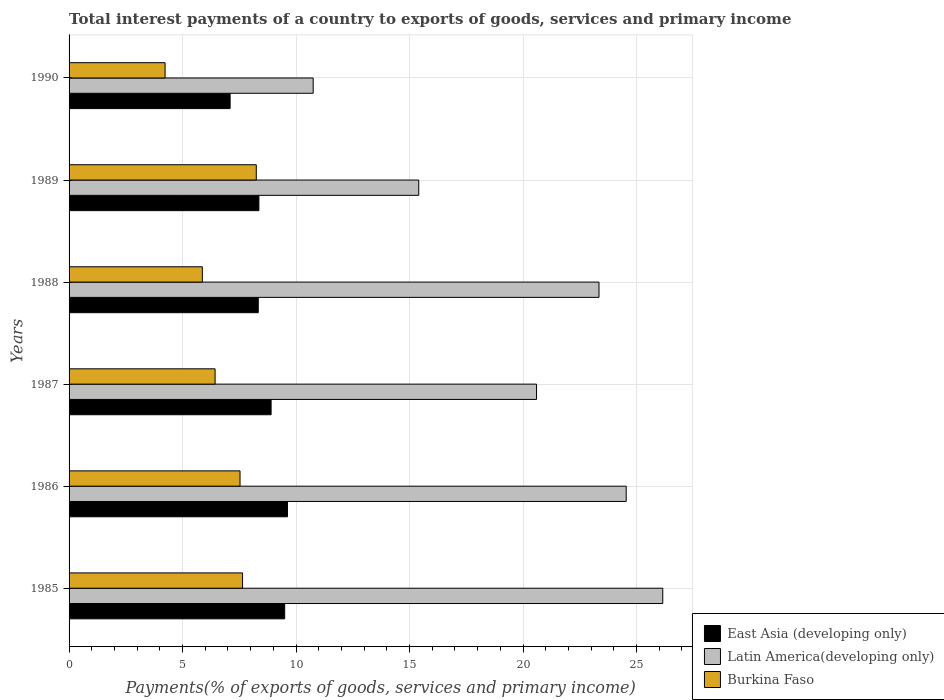How many groups of bars are there?
Give a very brief answer. 6. Are the number of bars on each tick of the Y-axis equal?
Provide a succinct answer. Yes. How many bars are there on the 4th tick from the top?
Your answer should be compact. 3. What is the label of the 6th group of bars from the top?
Your answer should be compact. 1985. In how many cases, is the number of bars for a given year not equal to the number of legend labels?
Make the answer very short. 0. What is the total interest payments in Latin America(developing only) in 1987?
Ensure brevity in your answer.  20.59. Across all years, what is the maximum total interest payments in East Asia (developing only)?
Make the answer very short. 9.62. Across all years, what is the minimum total interest payments in Latin America(developing only)?
Make the answer very short. 10.75. In which year was the total interest payments in Latin America(developing only) maximum?
Make the answer very short. 1985. In which year was the total interest payments in East Asia (developing only) minimum?
Give a very brief answer. 1990. What is the total total interest payments in Latin America(developing only) in the graph?
Keep it short and to the point. 120.8. What is the difference between the total interest payments in East Asia (developing only) in 1987 and that in 1989?
Your answer should be very brief. 0.54. What is the difference between the total interest payments in Burkina Faso in 1990 and the total interest payments in Latin America(developing only) in 1985?
Make the answer very short. -21.92. What is the average total interest payments in East Asia (developing only) per year?
Provide a short and direct response. 8.64. In the year 1989, what is the difference between the total interest payments in East Asia (developing only) and total interest payments in Latin America(developing only)?
Offer a terse response. -7.04. In how many years, is the total interest payments in East Asia (developing only) greater than 5 %?
Keep it short and to the point. 6. What is the ratio of the total interest payments in Latin America(developing only) in 1985 to that in 1988?
Offer a terse response. 1.12. Is the total interest payments in East Asia (developing only) in 1986 less than that in 1990?
Your answer should be compact. No. What is the difference between the highest and the second highest total interest payments in East Asia (developing only)?
Provide a succinct answer. 0.12. What is the difference between the highest and the lowest total interest payments in Burkina Faso?
Your answer should be very brief. 4.02. What does the 1st bar from the top in 1985 represents?
Provide a succinct answer. Burkina Faso. What does the 2nd bar from the bottom in 1989 represents?
Provide a succinct answer. Latin America(developing only). Is it the case that in every year, the sum of the total interest payments in East Asia (developing only) and total interest payments in Latin America(developing only) is greater than the total interest payments in Burkina Faso?
Make the answer very short. Yes. Are all the bars in the graph horizontal?
Your answer should be compact. Yes. How many years are there in the graph?
Your answer should be compact. 6. Are the values on the major ticks of X-axis written in scientific E-notation?
Your answer should be very brief. No. Does the graph contain any zero values?
Your response must be concise. No. How many legend labels are there?
Provide a short and direct response. 3. How are the legend labels stacked?
Provide a succinct answer. Vertical. What is the title of the graph?
Your answer should be very brief. Total interest payments of a country to exports of goods, services and primary income. Does "Peru" appear as one of the legend labels in the graph?
Offer a terse response. No. What is the label or title of the X-axis?
Your answer should be very brief. Payments(% of exports of goods, services and primary income). What is the label or title of the Y-axis?
Your answer should be compact. Years. What is the Payments(% of exports of goods, services and primary income) in East Asia (developing only) in 1985?
Your response must be concise. 9.5. What is the Payments(% of exports of goods, services and primary income) in Latin America(developing only) in 1985?
Ensure brevity in your answer.  26.15. What is the Payments(% of exports of goods, services and primary income) of Burkina Faso in 1985?
Give a very brief answer. 7.64. What is the Payments(% of exports of goods, services and primary income) in East Asia (developing only) in 1986?
Offer a very short reply. 9.62. What is the Payments(% of exports of goods, services and primary income) of Latin America(developing only) in 1986?
Your answer should be very brief. 24.54. What is the Payments(% of exports of goods, services and primary income) of Burkina Faso in 1986?
Provide a succinct answer. 7.53. What is the Payments(% of exports of goods, services and primary income) of East Asia (developing only) in 1987?
Your answer should be compact. 8.9. What is the Payments(% of exports of goods, services and primary income) of Latin America(developing only) in 1987?
Give a very brief answer. 20.59. What is the Payments(% of exports of goods, services and primary income) in Burkina Faso in 1987?
Offer a very short reply. 6.43. What is the Payments(% of exports of goods, services and primary income) of East Asia (developing only) in 1988?
Ensure brevity in your answer.  8.33. What is the Payments(% of exports of goods, services and primary income) in Latin America(developing only) in 1988?
Ensure brevity in your answer.  23.35. What is the Payments(% of exports of goods, services and primary income) in Burkina Faso in 1988?
Keep it short and to the point. 5.87. What is the Payments(% of exports of goods, services and primary income) of East Asia (developing only) in 1989?
Make the answer very short. 8.36. What is the Payments(% of exports of goods, services and primary income) of Latin America(developing only) in 1989?
Offer a very short reply. 15.4. What is the Payments(% of exports of goods, services and primary income) of Burkina Faso in 1989?
Your answer should be very brief. 8.25. What is the Payments(% of exports of goods, services and primary income) in East Asia (developing only) in 1990?
Your answer should be compact. 7.09. What is the Payments(% of exports of goods, services and primary income) of Latin America(developing only) in 1990?
Offer a very short reply. 10.75. What is the Payments(% of exports of goods, services and primary income) in Burkina Faso in 1990?
Provide a succinct answer. 4.23. Across all years, what is the maximum Payments(% of exports of goods, services and primary income) in East Asia (developing only)?
Your response must be concise. 9.62. Across all years, what is the maximum Payments(% of exports of goods, services and primary income) of Latin America(developing only)?
Ensure brevity in your answer.  26.15. Across all years, what is the maximum Payments(% of exports of goods, services and primary income) in Burkina Faso?
Provide a succinct answer. 8.25. Across all years, what is the minimum Payments(% of exports of goods, services and primary income) in East Asia (developing only)?
Your response must be concise. 7.09. Across all years, what is the minimum Payments(% of exports of goods, services and primary income) of Latin America(developing only)?
Offer a terse response. 10.75. Across all years, what is the minimum Payments(% of exports of goods, services and primary income) in Burkina Faso?
Provide a succinct answer. 4.23. What is the total Payments(% of exports of goods, services and primary income) in East Asia (developing only) in the graph?
Provide a succinct answer. 51.81. What is the total Payments(% of exports of goods, services and primary income) of Latin America(developing only) in the graph?
Offer a terse response. 120.8. What is the total Payments(% of exports of goods, services and primary income) of Burkina Faso in the graph?
Keep it short and to the point. 39.96. What is the difference between the Payments(% of exports of goods, services and primary income) of East Asia (developing only) in 1985 and that in 1986?
Offer a terse response. -0.12. What is the difference between the Payments(% of exports of goods, services and primary income) of Latin America(developing only) in 1985 and that in 1986?
Give a very brief answer. 1.61. What is the difference between the Payments(% of exports of goods, services and primary income) of Burkina Faso in 1985 and that in 1986?
Provide a succinct answer. 0.11. What is the difference between the Payments(% of exports of goods, services and primary income) of East Asia (developing only) in 1985 and that in 1987?
Provide a succinct answer. 0.6. What is the difference between the Payments(% of exports of goods, services and primary income) in Latin America(developing only) in 1985 and that in 1987?
Ensure brevity in your answer.  5.56. What is the difference between the Payments(% of exports of goods, services and primary income) of Burkina Faso in 1985 and that in 1987?
Make the answer very short. 1.21. What is the difference between the Payments(% of exports of goods, services and primary income) of East Asia (developing only) in 1985 and that in 1988?
Offer a very short reply. 1.16. What is the difference between the Payments(% of exports of goods, services and primary income) in Latin America(developing only) in 1985 and that in 1988?
Provide a succinct answer. 2.81. What is the difference between the Payments(% of exports of goods, services and primary income) of Burkina Faso in 1985 and that in 1988?
Offer a terse response. 1.77. What is the difference between the Payments(% of exports of goods, services and primary income) in East Asia (developing only) in 1985 and that in 1989?
Ensure brevity in your answer.  1.14. What is the difference between the Payments(% of exports of goods, services and primary income) in Latin America(developing only) in 1985 and that in 1989?
Your answer should be compact. 10.75. What is the difference between the Payments(% of exports of goods, services and primary income) in Burkina Faso in 1985 and that in 1989?
Your response must be concise. -0.6. What is the difference between the Payments(% of exports of goods, services and primary income) in East Asia (developing only) in 1985 and that in 1990?
Make the answer very short. 2.4. What is the difference between the Payments(% of exports of goods, services and primary income) in Burkina Faso in 1985 and that in 1990?
Your answer should be very brief. 3.41. What is the difference between the Payments(% of exports of goods, services and primary income) of East Asia (developing only) in 1986 and that in 1987?
Offer a terse response. 0.72. What is the difference between the Payments(% of exports of goods, services and primary income) in Latin America(developing only) in 1986 and that in 1987?
Give a very brief answer. 3.95. What is the difference between the Payments(% of exports of goods, services and primary income) in Burkina Faso in 1986 and that in 1987?
Your answer should be very brief. 1.1. What is the difference between the Payments(% of exports of goods, services and primary income) of East Asia (developing only) in 1986 and that in 1988?
Offer a terse response. 1.29. What is the difference between the Payments(% of exports of goods, services and primary income) of Latin America(developing only) in 1986 and that in 1988?
Give a very brief answer. 1.2. What is the difference between the Payments(% of exports of goods, services and primary income) of Burkina Faso in 1986 and that in 1988?
Your answer should be compact. 1.66. What is the difference between the Payments(% of exports of goods, services and primary income) in East Asia (developing only) in 1986 and that in 1989?
Your answer should be compact. 1.26. What is the difference between the Payments(% of exports of goods, services and primary income) in Latin America(developing only) in 1986 and that in 1989?
Your response must be concise. 9.14. What is the difference between the Payments(% of exports of goods, services and primary income) of Burkina Faso in 1986 and that in 1989?
Your answer should be very brief. -0.72. What is the difference between the Payments(% of exports of goods, services and primary income) of East Asia (developing only) in 1986 and that in 1990?
Ensure brevity in your answer.  2.53. What is the difference between the Payments(% of exports of goods, services and primary income) in Latin America(developing only) in 1986 and that in 1990?
Ensure brevity in your answer.  13.79. What is the difference between the Payments(% of exports of goods, services and primary income) in Burkina Faso in 1986 and that in 1990?
Offer a very short reply. 3.3. What is the difference between the Payments(% of exports of goods, services and primary income) of East Asia (developing only) in 1987 and that in 1988?
Your response must be concise. 0.57. What is the difference between the Payments(% of exports of goods, services and primary income) of Latin America(developing only) in 1987 and that in 1988?
Ensure brevity in your answer.  -2.75. What is the difference between the Payments(% of exports of goods, services and primary income) of Burkina Faso in 1987 and that in 1988?
Give a very brief answer. 0.56. What is the difference between the Payments(% of exports of goods, services and primary income) of East Asia (developing only) in 1987 and that in 1989?
Ensure brevity in your answer.  0.54. What is the difference between the Payments(% of exports of goods, services and primary income) of Latin America(developing only) in 1987 and that in 1989?
Your answer should be very brief. 5.19. What is the difference between the Payments(% of exports of goods, services and primary income) of Burkina Faso in 1987 and that in 1989?
Keep it short and to the point. -1.81. What is the difference between the Payments(% of exports of goods, services and primary income) of East Asia (developing only) in 1987 and that in 1990?
Keep it short and to the point. 1.81. What is the difference between the Payments(% of exports of goods, services and primary income) of Latin America(developing only) in 1987 and that in 1990?
Make the answer very short. 9.84. What is the difference between the Payments(% of exports of goods, services and primary income) in Burkina Faso in 1987 and that in 1990?
Your answer should be very brief. 2.2. What is the difference between the Payments(% of exports of goods, services and primary income) in East Asia (developing only) in 1988 and that in 1989?
Provide a succinct answer. -0.03. What is the difference between the Payments(% of exports of goods, services and primary income) of Latin America(developing only) in 1988 and that in 1989?
Ensure brevity in your answer.  7.94. What is the difference between the Payments(% of exports of goods, services and primary income) of Burkina Faso in 1988 and that in 1989?
Offer a very short reply. -2.38. What is the difference between the Payments(% of exports of goods, services and primary income) of East Asia (developing only) in 1988 and that in 1990?
Provide a succinct answer. 1.24. What is the difference between the Payments(% of exports of goods, services and primary income) in Latin America(developing only) in 1988 and that in 1990?
Make the answer very short. 12.59. What is the difference between the Payments(% of exports of goods, services and primary income) in Burkina Faso in 1988 and that in 1990?
Your answer should be compact. 1.64. What is the difference between the Payments(% of exports of goods, services and primary income) in East Asia (developing only) in 1989 and that in 1990?
Ensure brevity in your answer.  1.27. What is the difference between the Payments(% of exports of goods, services and primary income) of Latin America(developing only) in 1989 and that in 1990?
Your answer should be compact. 4.65. What is the difference between the Payments(% of exports of goods, services and primary income) in Burkina Faso in 1989 and that in 1990?
Provide a succinct answer. 4.02. What is the difference between the Payments(% of exports of goods, services and primary income) in East Asia (developing only) in 1985 and the Payments(% of exports of goods, services and primary income) in Latin America(developing only) in 1986?
Offer a terse response. -15.04. What is the difference between the Payments(% of exports of goods, services and primary income) in East Asia (developing only) in 1985 and the Payments(% of exports of goods, services and primary income) in Burkina Faso in 1986?
Make the answer very short. 1.97. What is the difference between the Payments(% of exports of goods, services and primary income) of Latin America(developing only) in 1985 and the Payments(% of exports of goods, services and primary income) of Burkina Faso in 1986?
Your answer should be compact. 18.62. What is the difference between the Payments(% of exports of goods, services and primary income) of East Asia (developing only) in 1985 and the Payments(% of exports of goods, services and primary income) of Latin America(developing only) in 1987?
Make the answer very short. -11.09. What is the difference between the Payments(% of exports of goods, services and primary income) in East Asia (developing only) in 1985 and the Payments(% of exports of goods, services and primary income) in Burkina Faso in 1987?
Make the answer very short. 3.07. What is the difference between the Payments(% of exports of goods, services and primary income) of Latin America(developing only) in 1985 and the Payments(% of exports of goods, services and primary income) of Burkina Faso in 1987?
Offer a terse response. 19.72. What is the difference between the Payments(% of exports of goods, services and primary income) in East Asia (developing only) in 1985 and the Payments(% of exports of goods, services and primary income) in Latin America(developing only) in 1988?
Keep it short and to the point. -13.85. What is the difference between the Payments(% of exports of goods, services and primary income) of East Asia (developing only) in 1985 and the Payments(% of exports of goods, services and primary income) of Burkina Faso in 1988?
Your answer should be very brief. 3.63. What is the difference between the Payments(% of exports of goods, services and primary income) of Latin America(developing only) in 1985 and the Payments(% of exports of goods, services and primary income) of Burkina Faso in 1988?
Your answer should be very brief. 20.28. What is the difference between the Payments(% of exports of goods, services and primary income) in East Asia (developing only) in 1985 and the Payments(% of exports of goods, services and primary income) in Latin America(developing only) in 1989?
Provide a succinct answer. -5.91. What is the difference between the Payments(% of exports of goods, services and primary income) of East Asia (developing only) in 1985 and the Payments(% of exports of goods, services and primary income) of Burkina Faso in 1989?
Give a very brief answer. 1.25. What is the difference between the Payments(% of exports of goods, services and primary income) of Latin America(developing only) in 1985 and the Payments(% of exports of goods, services and primary income) of Burkina Faso in 1989?
Offer a very short reply. 17.91. What is the difference between the Payments(% of exports of goods, services and primary income) of East Asia (developing only) in 1985 and the Payments(% of exports of goods, services and primary income) of Latin America(developing only) in 1990?
Ensure brevity in your answer.  -1.26. What is the difference between the Payments(% of exports of goods, services and primary income) of East Asia (developing only) in 1985 and the Payments(% of exports of goods, services and primary income) of Burkina Faso in 1990?
Offer a terse response. 5.27. What is the difference between the Payments(% of exports of goods, services and primary income) in Latin America(developing only) in 1985 and the Payments(% of exports of goods, services and primary income) in Burkina Faso in 1990?
Keep it short and to the point. 21.92. What is the difference between the Payments(% of exports of goods, services and primary income) in East Asia (developing only) in 1986 and the Payments(% of exports of goods, services and primary income) in Latin America(developing only) in 1987?
Offer a terse response. -10.97. What is the difference between the Payments(% of exports of goods, services and primary income) in East Asia (developing only) in 1986 and the Payments(% of exports of goods, services and primary income) in Burkina Faso in 1987?
Provide a succinct answer. 3.19. What is the difference between the Payments(% of exports of goods, services and primary income) in Latin America(developing only) in 1986 and the Payments(% of exports of goods, services and primary income) in Burkina Faso in 1987?
Offer a terse response. 18.11. What is the difference between the Payments(% of exports of goods, services and primary income) of East Asia (developing only) in 1986 and the Payments(% of exports of goods, services and primary income) of Latin America(developing only) in 1988?
Your response must be concise. -13.72. What is the difference between the Payments(% of exports of goods, services and primary income) of East Asia (developing only) in 1986 and the Payments(% of exports of goods, services and primary income) of Burkina Faso in 1988?
Your response must be concise. 3.75. What is the difference between the Payments(% of exports of goods, services and primary income) in Latin America(developing only) in 1986 and the Payments(% of exports of goods, services and primary income) in Burkina Faso in 1988?
Offer a terse response. 18.67. What is the difference between the Payments(% of exports of goods, services and primary income) in East Asia (developing only) in 1986 and the Payments(% of exports of goods, services and primary income) in Latin America(developing only) in 1989?
Offer a terse response. -5.78. What is the difference between the Payments(% of exports of goods, services and primary income) in East Asia (developing only) in 1986 and the Payments(% of exports of goods, services and primary income) in Burkina Faso in 1989?
Your response must be concise. 1.37. What is the difference between the Payments(% of exports of goods, services and primary income) of Latin America(developing only) in 1986 and the Payments(% of exports of goods, services and primary income) of Burkina Faso in 1989?
Your response must be concise. 16.3. What is the difference between the Payments(% of exports of goods, services and primary income) in East Asia (developing only) in 1986 and the Payments(% of exports of goods, services and primary income) in Latin America(developing only) in 1990?
Make the answer very short. -1.13. What is the difference between the Payments(% of exports of goods, services and primary income) of East Asia (developing only) in 1986 and the Payments(% of exports of goods, services and primary income) of Burkina Faso in 1990?
Give a very brief answer. 5.39. What is the difference between the Payments(% of exports of goods, services and primary income) in Latin America(developing only) in 1986 and the Payments(% of exports of goods, services and primary income) in Burkina Faso in 1990?
Provide a short and direct response. 20.31. What is the difference between the Payments(% of exports of goods, services and primary income) in East Asia (developing only) in 1987 and the Payments(% of exports of goods, services and primary income) in Latin America(developing only) in 1988?
Ensure brevity in your answer.  -14.45. What is the difference between the Payments(% of exports of goods, services and primary income) in East Asia (developing only) in 1987 and the Payments(% of exports of goods, services and primary income) in Burkina Faso in 1988?
Provide a short and direct response. 3.03. What is the difference between the Payments(% of exports of goods, services and primary income) in Latin America(developing only) in 1987 and the Payments(% of exports of goods, services and primary income) in Burkina Faso in 1988?
Offer a terse response. 14.72. What is the difference between the Payments(% of exports of goods, services and primary income) in East Asia (developing only) in 1987 and the Payments(% of exports of goods, services and primary income) in Latin America(developing only) in 1989?
Your response must be concise. -6.5. What is the difference between the Payments(% of exports of goods, services and primary income) of East Asia (developing only) in 1987 and the Payments(% of exports of goods, services and primary income) of Burkina Faso in 1989?
Keep it short and to the point. 0.65. What is the difference between the Payments(% of exports of goods, services and primary income) of Latin America(developing only) in 1987 and the Payments(% of exports of goods, services and primary income) of Burkina Faso in 1989?
Your answer should be compact. 12.35. What is the difference between the Payments(% of exports of goods, services and primary income) in East Asia (developing only) in 1987 and the Payments(% of exports of goods, services and primary income) in Latin America(developing only) in 1990?
Your answer should be very brief. -1.85. What is the difference between the Payments(% of exports of goods, services and primary income) of East Asia (developing only) in 1987 and the Payments(% of exports of goods, services and primary income) of Burkina Faso in 1990?
Your response must be concise. 4.67. What is the difference between the Payments(% of exports of goods, services and primary income) of Latin America(developing only) in 1987 and the Payments(% of exports of goods, services and primary income) of Burkina Faso in 1990?
Keep it short and to the point. 16.36. What is the difference between the Payments(% of exports of goods, services and primary income) of East Asia (developing only) in 1988 and the Payments(% of exports of goods, services and primary income) of Latin America(developing only) in 1989?
Provide a short and direct response. -7.07. What is the difference between the Payments(% of exports of goods, services and primary income) of East Asia (developing only) in 1988 and the Payments(% of exports of goods, services and primary income) of Burkina Faso in 1989?
Provide a short and direct response. 0.09. What is the difference between the Payments(% of exports of goods, services and primary income) in Latin America(developing only) in 1988 and the Payments(% of exports of goods, services and primary income) in Burkina Faso in 1989?
Offer a very short reply. 15.1. What is the difference between the Payments(% of exports of goods, services and primary income) in East Asia (developing only) in 1988 and the Payments(% of exports of goods, services and primary income) in Latin America(developing only) in 1990?
Provide a succinct answer. -2.42. What is the difference between the Payments(% of exports of goods, services and primary income) in East Asia (developing only) in 1988 and the Payments(% of exports of goods, services and primary income) in Burkina Faso in 1990?
Your answer should be very brief. 4.1. What is the difference between the Payments(% of exports of goods, services and primary income) of Latin America(developing only) in 1988 and the Payments(% of exports of goods, services and primary income) of Burkina Faso in 1990?
Offer a very short reply. 19.12. What is the difference between the Payments(% of exports of goods, services and primary income) of East Asia (developing only) in 1989 and the Payments(% of exports of goods, services and primary income) of Latin America(developing only) in 1990?
Give a very brief answer. -2.39. What is the difference between the Payments(% of exports of goods, services and primary income) in East Asia (developing only) in 1989 and the Payments(% of exports of goods, services and primary income) in Burkina Faso in 1990?
Your answer should be compact. 4.13. What is the difference between the Payments(% of exports of goods, services and primary income) in Latin America(developing only) in 1989 and the Payments(% of exports of goods, services and primary income) in Burkina Faso in 1990?
Offer a terse response. 11.18. What is the average Payments(% of exports of goods, services and primary income) in East Asia (developing only) per year?
Your answer should be very brief. 8.64. What is the average Payments(% of exports of goods, services and primary income) of Latin America(developing only) per year?
Your answer should be compact. 20.13. What is the average Payments(% of exports of goods, services and primary income) of Burkina Faso per year?
Offer a very short reply. 6.66. In the year 1985, what is the difference between the Payments(% of exports of goods, services and primary income) of East Asia (developing only) and Payments(% of exports of goods, services and primary income) of Latin America(developing only)?
Offer a very short reply. -16.66. In the year 1985, what is the difference between the Payments(% of exports of goods, services and primary income) of East Asia (developing only) and Payments(% of exports of goods, services and primary income) of Burkina Faso?
Keep it short and to the point. 1.86. In the year 1985, what is the difference between the Payments(% of exports of goods, services and primary income) of Latin America(developing only) and Payments(% of exports of goods, services and primary income) of Burkina Faso?
Make the answer very short. 18.51. In the year 1986, what is the difference between the Payments(% of exports of goods, services and primary income) in East Asia (developing only) and Payments(% of exports of goods, services and primary income) in Latin America(developing only)?
Give a very brief answer. -14.92. In the year 1986, what is the difference between the Payments(% of exports of goods, services and primary income) of East Asia (developing only) and Payments(% of exports of goods, services and primary income) of Burkina Faso?
Give a very brief answer. 2.09. In the year 1986, what is the difference between the Payments(% of exports of goods, services and primary income) of Latin America(developing only) and Payments(% of exports of goods, services and primary income) of Burkina Faso?
Your answer should be compact. 17.01. In the year 1987, what is the difference between the Payments(% of exports of goods, services and primary income) of East Asia (developing only) and Payments(% of exports of goods, services and primary income) of Latin America(developing only)?
Your response must be concise. -11.69. In the year 1987, what is the difference between the Payments(% of exports of goods, services and primary income) in East Asia (developing only) and Payments(% of exports of goods, services and primary income) in Burkina Faso?
Your response must be concise. 2.47. In the year 1987, what is the difference between the Payments(% of exports of goods, services and primary income) in Latin America(developing only) and Payments(% of exports of goods, services and primary income) in Burkina Faso?
Give a very brief answer. 14.16. In the year 1988, what is the difference between the Payments(% of exports of goods, services and primary income) of East Asia (developing only) and Payments(% of exports of goods, services and primary income) of Latin America(developing only)?
Your answer should be compact. -15.01. In the year 1988, what is the difference between the Payments(% of exports of goods, services and primary income) of East Asia (developing only) and Payments(% of exports of goods, services and primary income) of Burkina Faso?
Provide a succinct answer. 2.46. In the year 1988, what is the difference between the Payments(% of exports of goods, services and primary income) in Latin America(developing only) and Payments(% of exports of goods, services and primary income) in Burkina Faso?
Your response must be concise. 17.47. In the year 1989, what is the difference between the Payments(% of exports of goods, services and primary income) in East Asia (developing only) and Payments(% of exports of goods, services and primary income) in Latin America(developing only)?
Ensure brevity in your answer.  -7.04. In the year 1989, what is the difference between the Payments(% of exports of goods, services and primary income) of East Asia (developing only) and Payments(% of exports of goods, services and primary income) of Burkina Faso?
Your answer should be very brief. 0.12. In the year 1989, what is the difference between the Payments(% of exports of goods, services and primary income) of Latin America(developing only) and Payments(% of exports of goods, services and primary income) of Burkina Faso?
Provide a short and direct response. 7.16. In the year 1990, what is the difference between the Payments(% of exports of goods, services and primary income) in East Asia (developing only) and Payments(% of exports of goods, services and primary income) in Latin America(developing only)?
Make the answer very short. -3.66. In the year 1990, what is the difference between the Payments(% of exports of goods, services and primary income) in East Asia (developing only) and Payments(% of exports of goods, services and primary income) in Burkina Faso?
Give a very brief answer. 2.87. In the year 1990, what is the difference between the Payments(% of exports of goods, services and primary income) of Latin America(developing only) and Payments(% of exports of goods, services and primary income) of Burkina Faso?
Offer a terse response. 6.52. What is the ratio of the Payments(% of exports of goods, services and primary income) in East Asia (developing only) in 1985 to that in 1986?
Offer a terse response. 0.99. What is the ratio of the Payments(% of exports of goods, services and primary income) of Latin America(developing only) in 1985 to that in 1986?
Offer a terse response. 1.07. What is the ratio of the Payments(% of exports of goods, services and primary income) in Burkina Faso in 1985 to that in 1986?
Offer a terse response. 1.01. What is the ratio of the Payments(% of exports of goods, services and primary income) in East Asia (developing only) in 1985 to that in 1987?
Give a very brief answer. 1.07. What is the ratio of the Payments(% of exports of goods, services and primary income) of Latin America(developing only) in 1985 to that in 1987?
Your answer should be compact. 1.27. What is the ratio of the Payments(% of exports of goods, services and primary income) of Burkina Faso in 1985 to that in 1987?
Offer a terse response. 1.19. What is the ratio of the Payments(% of exports of goods, services and primary income) in East Asia (developing only) in 1985 to that in 1988?
Provide a succinct answer. 1.14. What is the ratio of the Payments(% of exports of goods, services and primary income) in Latin America(developing only) in 1985 to that in 1988?
Ensure brevity in your answer.  1.12. What is the ratio of the Payments(% of exports of goods, services and primary income) in Burkina Faso in 1985 to that in 1988?
Offer a very short reply. 1.3. What is the ratio of the Payments(% of exports of goods, services and primary income) of East Asia (developing only) in 1985 to that in 1989?
Your response must be concise. 1.14. What is the ratio of the Payments(% of exports of goods, services and primary income) of Latin America(developing only) in 1985 to that in 1989?
Offer a very short reply. 1.7. What is the ratio of the Payments(% of exports of goods, services and primary income) in Burkina Faso in 1985 to that in 1989?
Provide a succinct answer. 0.93. What is the ratio of the Payments(% of exports of goods, services and primary income) of East Asia (developing only) in 1985 to that in 1990?
Keep it short and to the point. 1.34. What is the ratio of the Payments(% of exports of goods, services and primary income) of Latin America(developing only) in 1985 to that in 1990?
Give a very brief answer. 2.43. What is the ratio of the Payments(% of exports of goods, services and primary income) in Burkina Faso in 1985 to that in 1990?
Keep it short and to the point. 1.81. What is the ratio of the Payments(% of exports of goods, services and primary income) in East Asia (developing only) in 1986 to that in 1987?
Provide a short and direct response. 1.08. What is the ratio of the Payments(% of exports of goods, services and primary income) of Latin America(developing only) in 1986 to that in 1987?
Keep it short and to the point. 1.19. What is the ratio of the Payments(% of exports of goods, services and primary income) of Burkina Faso in 1986 to that in 1987?
Offer a terse response. 1.17. What is the ratio of the Payments(% of exports of goods, services and primary income) of East Asia (developing only) in 1986 to that in 1988?
Your answer should be compact. 1.15. What is the ratio of the Payments(% of exports of goods, services and primary income) of Latin America(developing only) in 1986 to that in 1988?
Ensure brevity in your answer.  1.05. What is the ratio of the Payments(% of exports of goods, services and primary income) in Burkina Faso in 1986 to that in 1988?
Ensure brevity in your answer.  1.28. What is the ratio of the Payments(% of exports of goods, services and primary income) of East Asia (developing only) in 1986 to that in 1989?
Your answer should be very brief. 1.15. What is the ratio of the Payments(% of exports of goods, services and primary income) in Latin America(developing only) in 1986 to that in 1989?
Your answer should be compact. 1.59. What is the ratio of the Payments(% of exports of goods, services and primary income) of Burkina Faso in 1986 to that in 1989?
Your answer should be compact. 0.91. What is the ratio of the Payments(% of exports of goods, services and primary income) of East Asia (developing only) in 1986 to that in 1990?
Keep it short and to the point. 1.36. What is the ratio of the Payments(% of exports of goods, services and primary income) of Latin America(developing only) in 1986 to that in 1990?
Your response must be concise. 2.28. What is the ratio of the Payments(% of exports of goods, services and primary income) in Burkina Faso in 1986 to that in 1990?
Offer a terse response. 1.78. What is the ratio of the Payments(% of exports of goods, services and primary income) in East Asia (developing only) in 1987 to that in 1988?
Provide a succinct answer. 1.07. What is the ratio of the Payments(% of exports of goods, services and primary income) of Latin America(developing only) in 1987 to that in 1988?
Your answer should be very brief. 0.88. What is the ratio of the Payments(% of exports of goods, services and primary income) in Burkina Faso in 1987 to that in 1988?
Your answer should be compact. 1.1. What is the ratio of the Payments(% of exports of goods, services and primary income) in East Asia (developing only) in 1987 to that in 1989?
Your answer should be very brief. 1.06. What is the ratio of the Payments(% of exports of goods, services and primary income) in Latin America(developing only) in 1987 to that in 1989?
Provide a short and direct response. 1.34. What is the ratio of the Payments(% of exports of goods, services and primary income) of Burkina Faso in 1987 to that in 1989?
Your response must be concise. 0.78. What is the ratio of the Payments(% of exports of goods, services and primary income) in East Asia (developing only) in 1987 to that in 1990?
Your response must be concise. 1.25. What is the ratio of the Payments(% of exports of goods, services and primary income) in Latin America(developing only) in 1987 to that in 1990?
Your answer should be very brief. 1.91. What is the ratio of the Payments(% of exports of goods, services and primary income) of Burkina Faso in 1987 to that in 1990?
Ensure brevity in your answer.  1.52. What is the ratio of the Payments(% of exports of goods, services and primary income) in East Asia (developing only) in 1988 to that in 1989?
Keep it short and to the point. 1. What is the ratio of the Payments(% of exports of goods, services and primary income) in Latin America(developing only) in 1988 to that in 1989?
Your answer should be very brief. 1.52. What is the ratio of the Payments(% of exports of goods, services and primary income) in Burkina Faso in 1988 to that in 1989?
Your response must be concise. 0.71. What is the ratio of the Payments(% of exports of goods, services and primary income) in East Asia (developing only) in 1988 to that in 1990?
Your answer should be compact. 1.17. What is the ratio of the Payments(% of exports of goods, services and primary income) in Latin America(developing only) in 1988 to that in 1990?
Your response must be concise. 2.17. What is the ratio of the Payments(% of exports of goods, services and primary income) of Burkina Faso in 1988 to that in 1990?
Your response must be concise. 1.39. What is the ratio of the Payments(% of exports of goods, services and primary income) of East Asia (developing only) in 1989 to that in 1990?
Provide a succinct answer. 1.18. What is the ratio of the Payments(% of exports of goods, services and primary income) in Latin America(developing only) in 1989 to that in 1990?
Your answer should be compact. 1.43. What is the ratio of the Payments(% of exports of goods, services and primary income) in Burkina Faso in 1989 to that in 1990?
Your response must be concise. 1.95. What is the difference between the highest and the second highest Payments(% of exports of goods, services and primary income) of East Asia (developing only)?
Provide a short and direct response. 0.12. What is the difference between the highest and the second highest Payments(% of exports of goods, services and primary income) of Latin America(developing only)?
Provide a succinct answer. 1.61. What is the difference between the highest and the second highest Payments(% of exports of goods, services and primary income) of Burkina Faso?
Keep it short and to the point. 0.6. What is the difference between the highest and the lowest Payments(% of exports of goods, services and primary income) in East Asia (developing only)?
Offer a terse response. 2.53. What is the difference between the highest and the lowest Payments(% of exports of goods, services and primary income) of Latin America(developing only)?
Provide a short and direct response. 15.4. What is the difference between the highest and the lowest Payments(% of exports of goods, services and primary income) in Burkina Faso?
Offer a terse response. 4.02. 